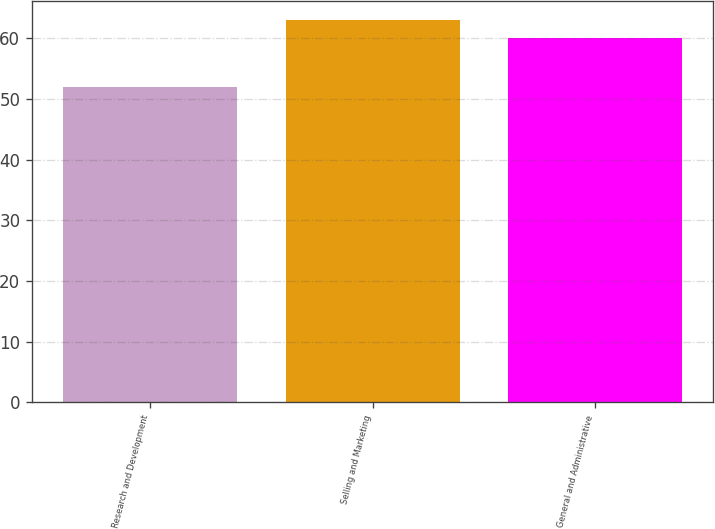Convert chart. <chart><loc_0><loc_0><loc_500><loc_500><bar_chart><fcel>Research and Development<fcel>Selling and Marketing<fcel>General and Administrative<nl><fcel>52<fcel>63<fcel>60<nl></chart> 